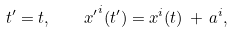Convert formula to latex. <formula><loc_0><loc_0><loc_500><loc_500>t ^ { \prime } = t , \quad { x ^ { \prime } } ^ { i } ( t ^ { \prime } ) = x ^ { i } ( t ) \, + \, a ^ { i } ,</formula> 